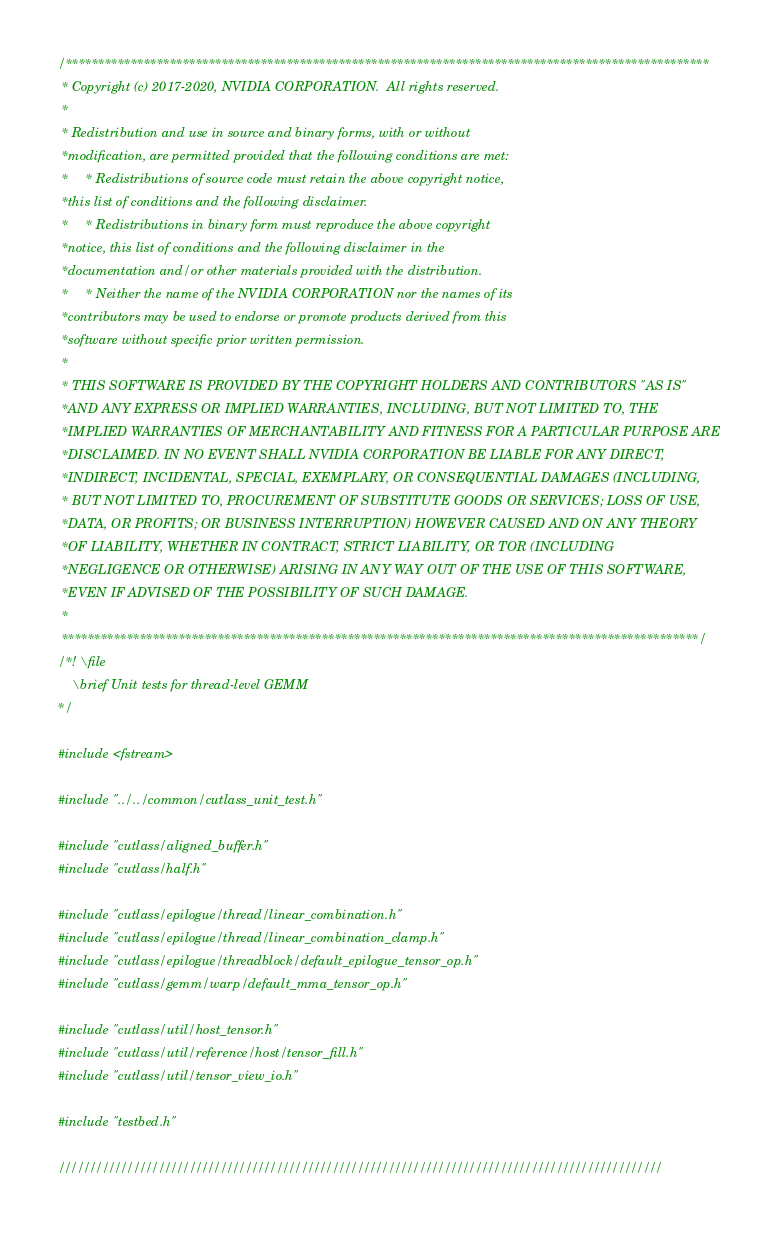Convert code to text. <code><loc_0><loc_0><loc_500><loc_500><_Cuda_>/***************************************************************************************************
 * Copyright (c) 2017-2020, NVIDIA CORPORATION.  All rights reserved.
 *
 * Redistribution and use in source and binary forms, with or without
 *modification, are permitted provided that the following conditions are met:
 *     * Redistributions of source code must retain the above copyright notice,
 *this list of conditions and the following disclaimer.
 *     * Redistributions in binary form must reproduce the above copyright
 *notice, this list of conditions and the following disclaimer in the
 *documentation and/or other materials provided with the distribution.
 *     * Neither the name of the NVIDIA CORPORATION nor the names of its
 *contributors may be used to endorse or promote products derived from this
 *software without specific prior written permission.
 *
 * THIS SOFTWARE IS PROVIDED BY THE COPYRIGHT HOLDERS AND CONTRIBUTORS "AS IS"
 *AND ANY EXPRESS OR IMPLIED WARRANTIES, INCLUDING, BUT NOT LIMITED TO, THE
 *IMPLIED WARRANTIES OF MERCHANTABILITY AND FITNESS FOR A PARTICULAR PURPOSE ARE
 *DISCLAIMED. IN NO EVENT SHALL NVIDIA CORPORATION BE LIABLE FOR ANY DIRECT,
 *INDIRECT, INCIDENTAL, SPECIAL, EXEMPLARY, OR CONSEQUENTIAL DAMAGES (INCLUDING,
 * BUT NOT LIMITED TO, PROCUREMENT OF SUBSTITUTE GOODS OR SERVICES; LOSS OF USE,
 *DATA, OR PROFITS; OR BUSINESS INTERRUPTION) HOWEVER CAUSED AND ON ANY THEORY
 *OF LIABILITY, WHETHER IN CONTRACT, STRICT LIABILITY, OR TOR (INCLUDING
 *NEGLIGENCE OR OTHERWISE) ARISING IN ANY WAY OUT OF THE USE OF THIS SOFTWARE,
 *EVEN IF ADVISED OF THE POSSIBILITY OF SUCH DAMAGE.
 *
 **************************************************************************************************/
/*! \file
    \brief Unit tests for thread-level GEMM
*/

#include <fstream>

#include "../../common/cutlass_unit_test.h"

#include "cutlass/aligned_buffer.h"
#include "cutlass/half.h"

#include "cutlass/epilogue/thread/linear_combination.h"
#include "cutlass/epilogue/thread/linear_combination_clamp.h"
#include "cutlass/epilogue/threadblock/default_epilogue_tensor_op.h"
#include "cutlass/gemm/warp/default_mma_tensor_op.h"

#include "cutlass/util/host_tensor.h"
#include "cutlass/util/reference/host/tensor_fill.h"
#include "cutlass/util/tensor_view_io.h"

#include "testbed.h"

/////////////////////////////////////////////////////////////////////////////////////////////////
</code> 